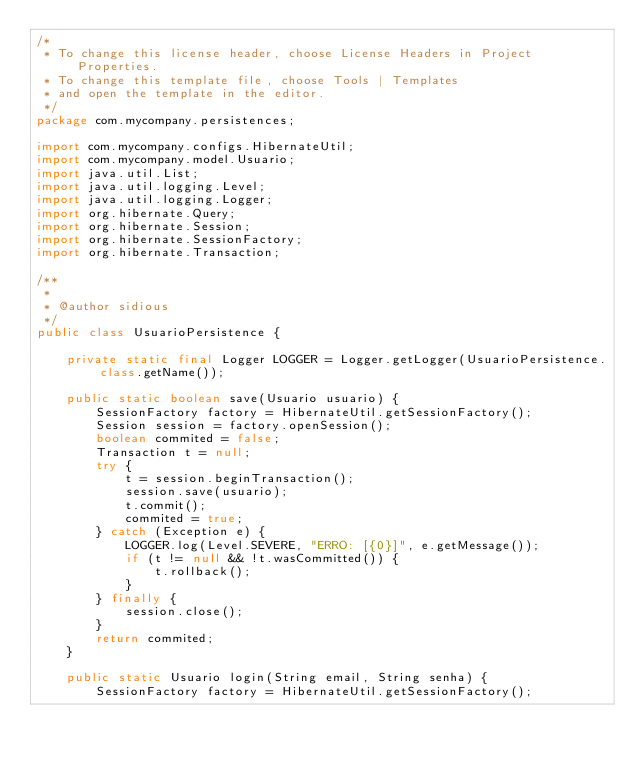<code> <loc_0><loc_0><loc_500><loc_500><_Java_>/*
 * To change this license header, choose License Headers in Project Properties.
 * To change this template file, choose Tools | Templates
 * and open the template in the editor.
 */
package com.mycompany.persistences;

import com.mycompany.configs.HibernateUtil;
import com.mycompany.model.Usuario;
import java.util.List;
import java.util.logging.Level;
import java.util.logging.Logger;
import org.hibernate.Query;
import org.hibernate.Session;
import org.hibernate.SessionFactory;
import org.hibernate.Transaction;

/**
 *
 * @author sidious
 */
public class UsuarioPersistence {

    private static final Logger LOGGER = Logger.getLogger(UsuarioPersistence.class.getName());

    public static boolean save(Usuario usuario) {
        SessionFactory factory = HibernateUtil.getSessionFactory();
        Session session = factory.openSession();
        boolean commited = false;
        Transaction t = null;
        try {
            t = session.beginTransaction();
            session.save(usuario);
            t.commit();
            commited = true;
        } catch (Exception e) {
            LOGGER.log(Level.SEVERE, "ERRO: [{0}]", e.getMessage());
            if (t != null && !t.wasCommitted()) {
                t.rollback();
            }
        } finally {
            session.close();
        }
        return commited;
    }

    public static Usuario login(String email, String senha) {
        SessionFactory factory = HibernateUtil.getSessionFactory();</code> 